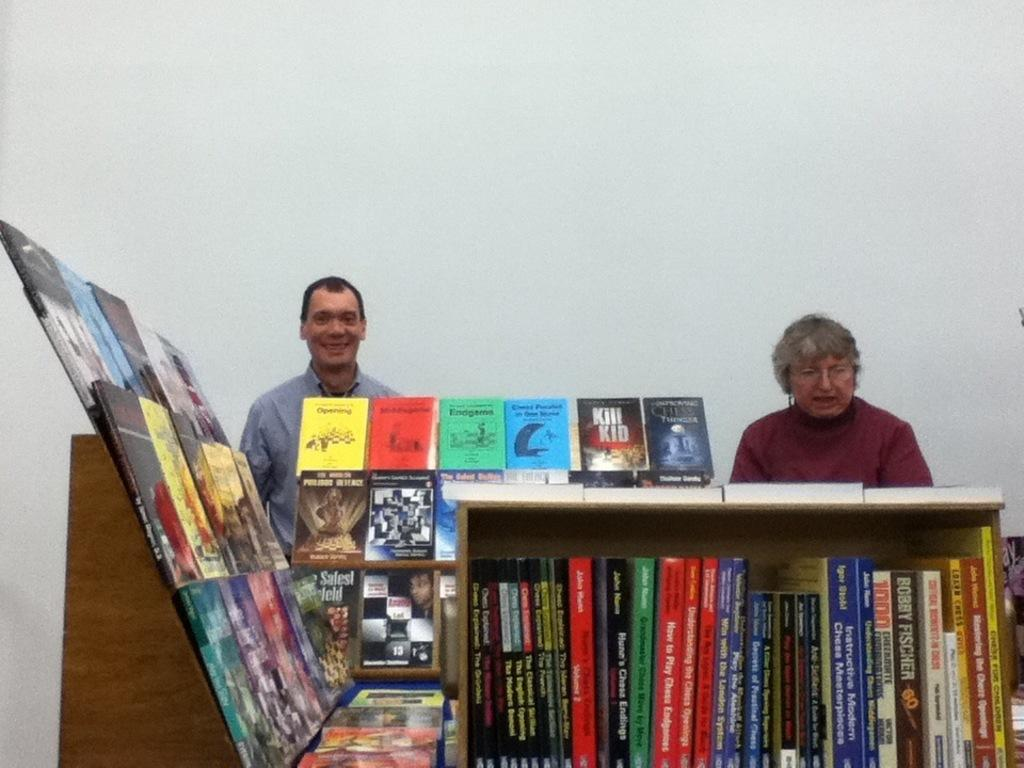<image>
Offer a succinct explanation of the picture presented. A man and women stand behind a shelf of books with title "Kill Kid" on top of the shelf with other books. 